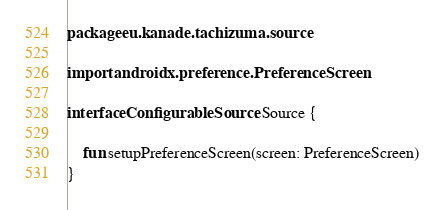<code> <loc_0><loc_0><loc_500><loc_500><_Kotlin_>package eu.kanade.tachizuma.source

import androidx.preference.PreferenceScreen

interface ConfigurableSource : Source {

    fun setupPreferenceScreen(screen: PreferenceScreen)
}
</code> 